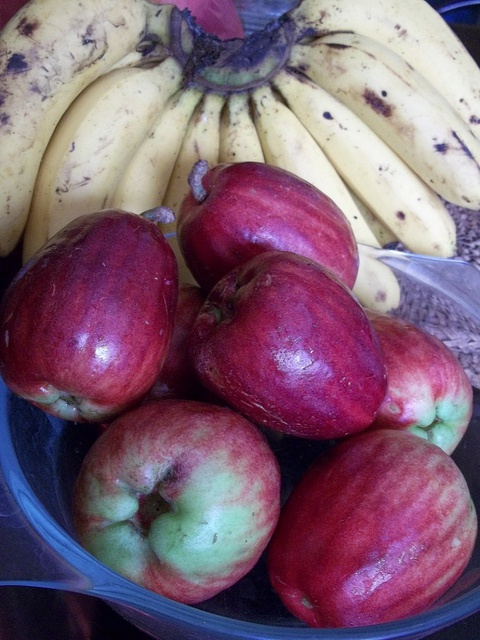Describe the objects in this image and their specific colors. I can see banana in purple, lightgray, darkgray, and gray tones, bowl in purple, black, navy, blue, and gray tones, apple in purple, gray, darkgray, and maroon tones, apple in purple, maroon, and violet tones, and apple in purple and black tones in this image. 